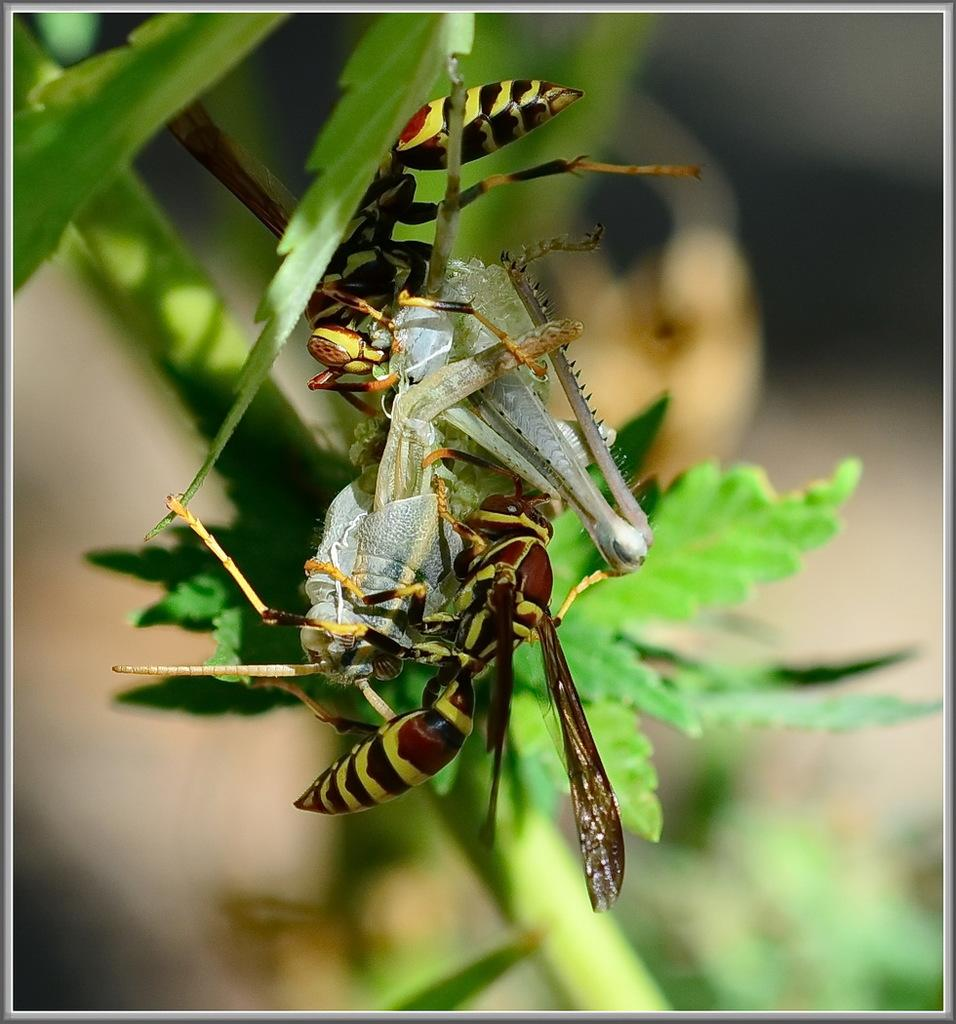What type of organisms can be seen on the plant in the image? There are insects on the plant in the image. What part of the plant is visible in the image? The plant has leaves. Can you describe the background of the image? The background of the image is blurry. What type of beast can be seen pulling the plant in the image? There is no beast present in the image, and the plant is not being pulled. 